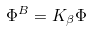Convert formula to latex. <formula><loc_0><loc_0><loc_500><loc_500>\Phi ^ { B } = K _ { \beta } \Phi</formula> 